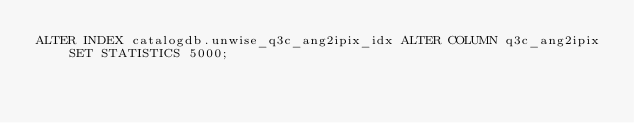<code> <loc_0><loc_0><loc_500><loc_500><_SQL_>ALTER INDEX catalogdb.unwise_q3c_ang2ipix_idx ALTER COLUMN q3c_ang2ipix SET STATISTICS 5000;
</code> 